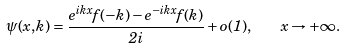<formula> <loc_0><loc_0><loc_500><loc_500>\psi ( x , k ) = \frac { e ^ { i k x } f ( - k ) - e ^ { - i k x } f ( k ) } { 2 i } + o ( 1 ) , \quad x \to + \infty .</formula> 